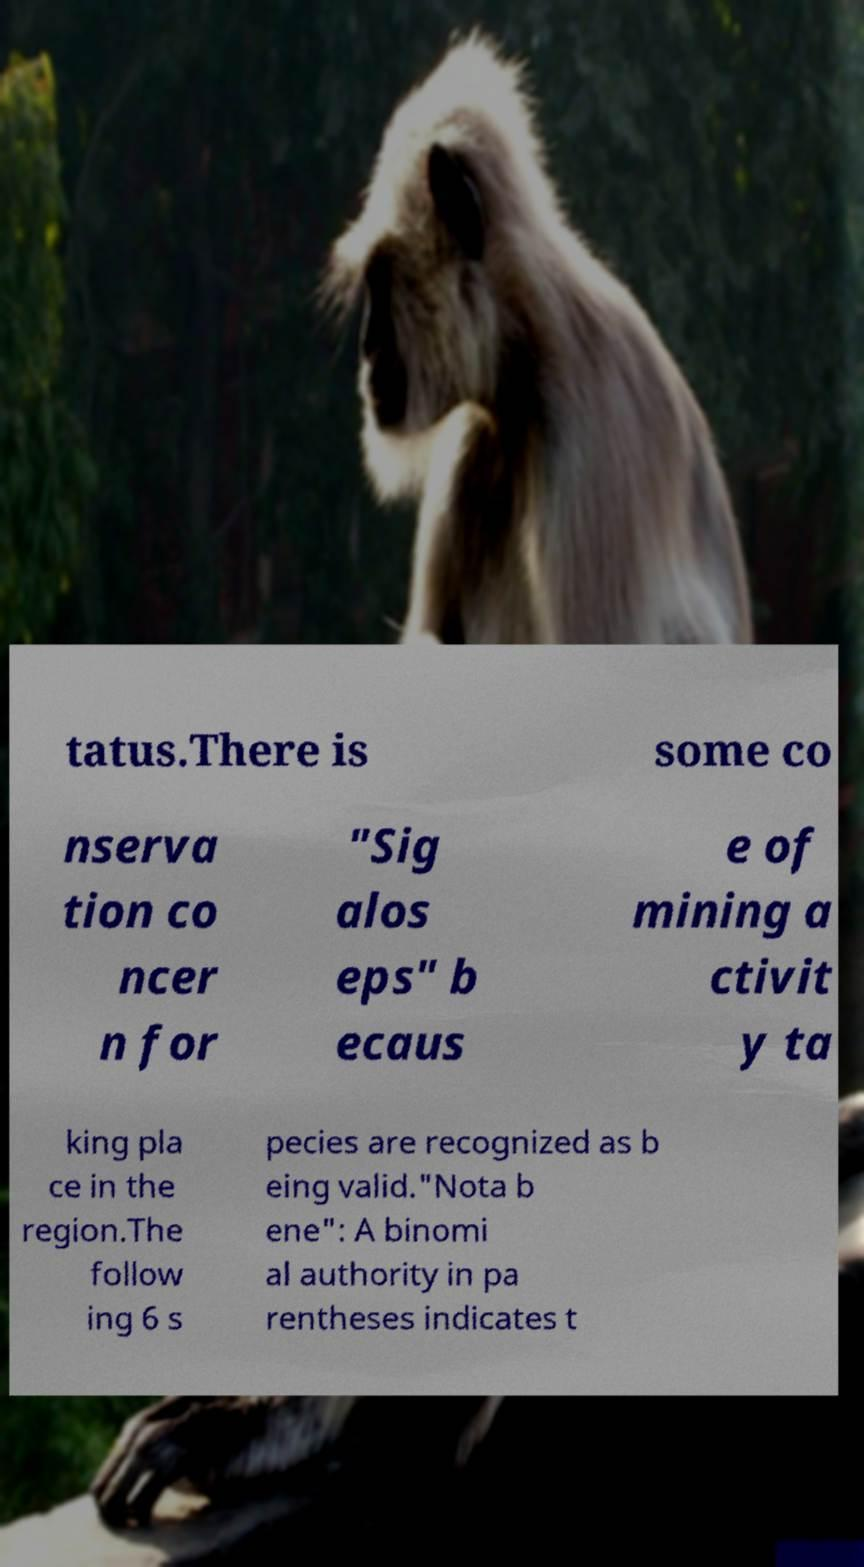Could you assist in decoding the text presented in this image and type it out clearly? tatus.There is some co nserva tion co ncer n for "Sig alos eps" b ecaus e of mining a ctivit y ta king pla ce in the region.The follow ing 6 s pecies are recognized as b eing valid."Nota b ene": A binomi al authority in pa rentheses indicates t 